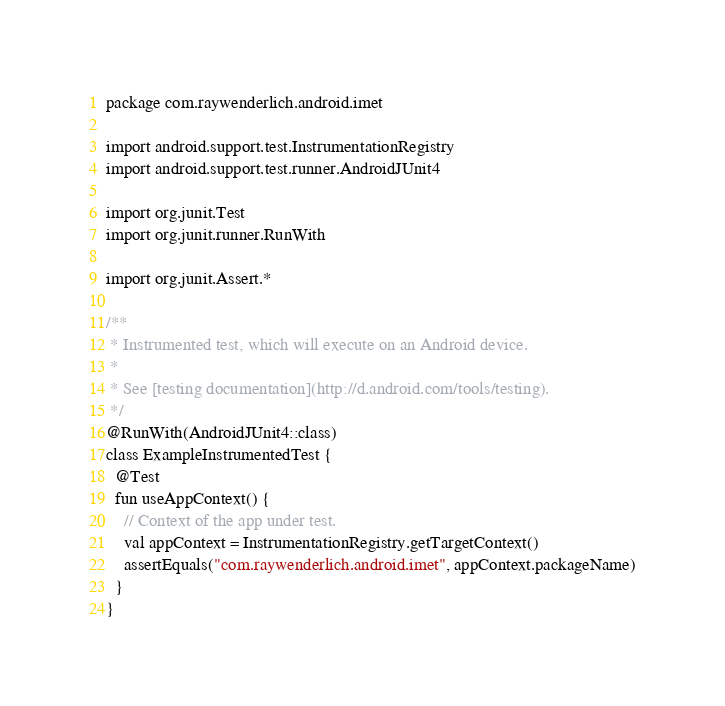<code> <loc_0><loc_0><loc_500><loc_500><_Kotlin_>package com.raywenderlich.android.imet

import android.support.test.InstrumentationRegistry
import android.support.test.runner.AndroidJUnit4

import org.junit.Test
import org.junit.runner.RunWith

import org.junit.Assert.*

/**
 * Instrumented test, which will execute on an Android device.
 *
 * See [testing documentation](http://d.android.com/tools/testing).
 */
@RunWith(AndroidJUnit4::class)
class ExampleInstrumentedTest {
  @Test
  fun useAppContext() {
    // Context of the app under test.
    val appContext = InstrumentationRegistry.getTargetContext()
    assertEquals("com.raywenderlich.android.imet", appContext.packageName)
  }
}
</code> 